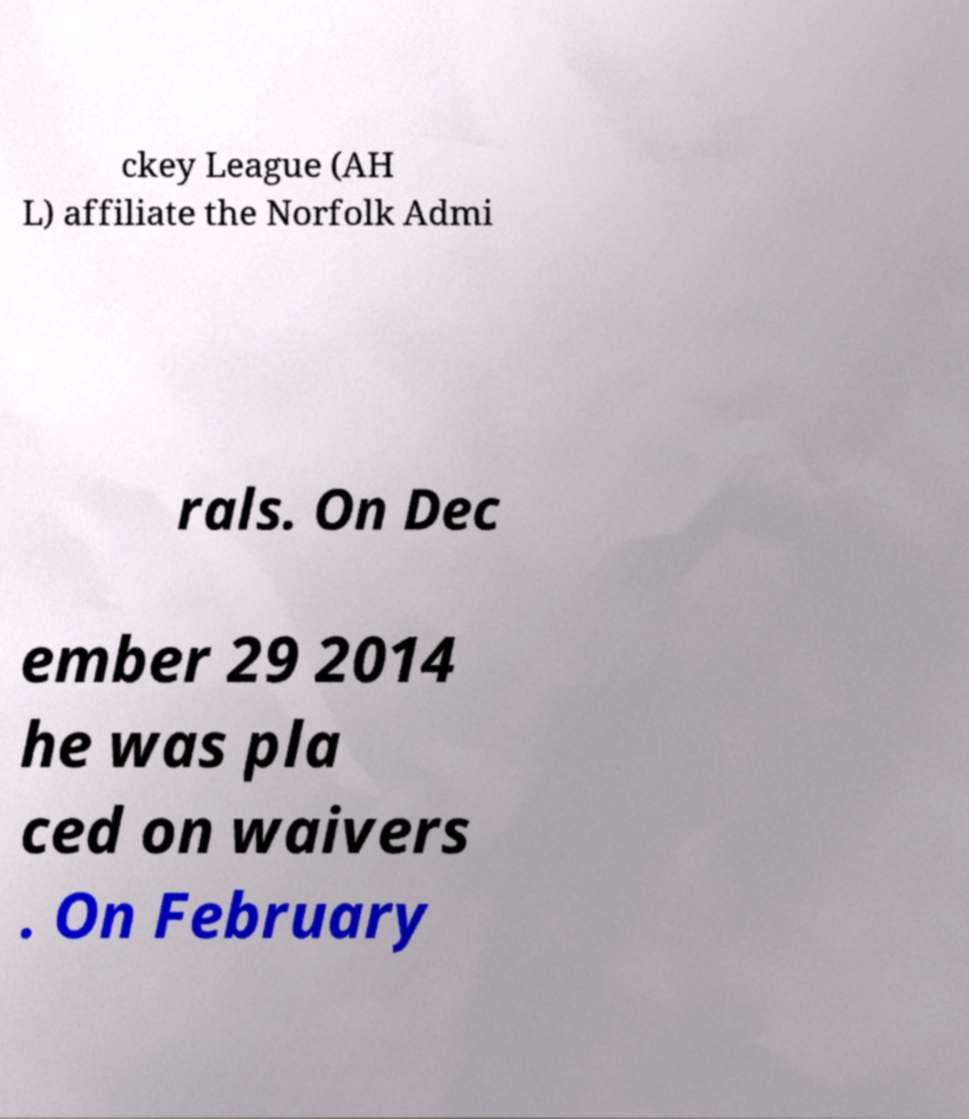Can you read and provide the text displayed in the image?This photo seems to have some interesting text. Can you extract and type it out for me? ckey League (AH L) affiliate the Norfolk Admi rals. On Dec ember 29 2014 he was pla ced on waivers . On February 